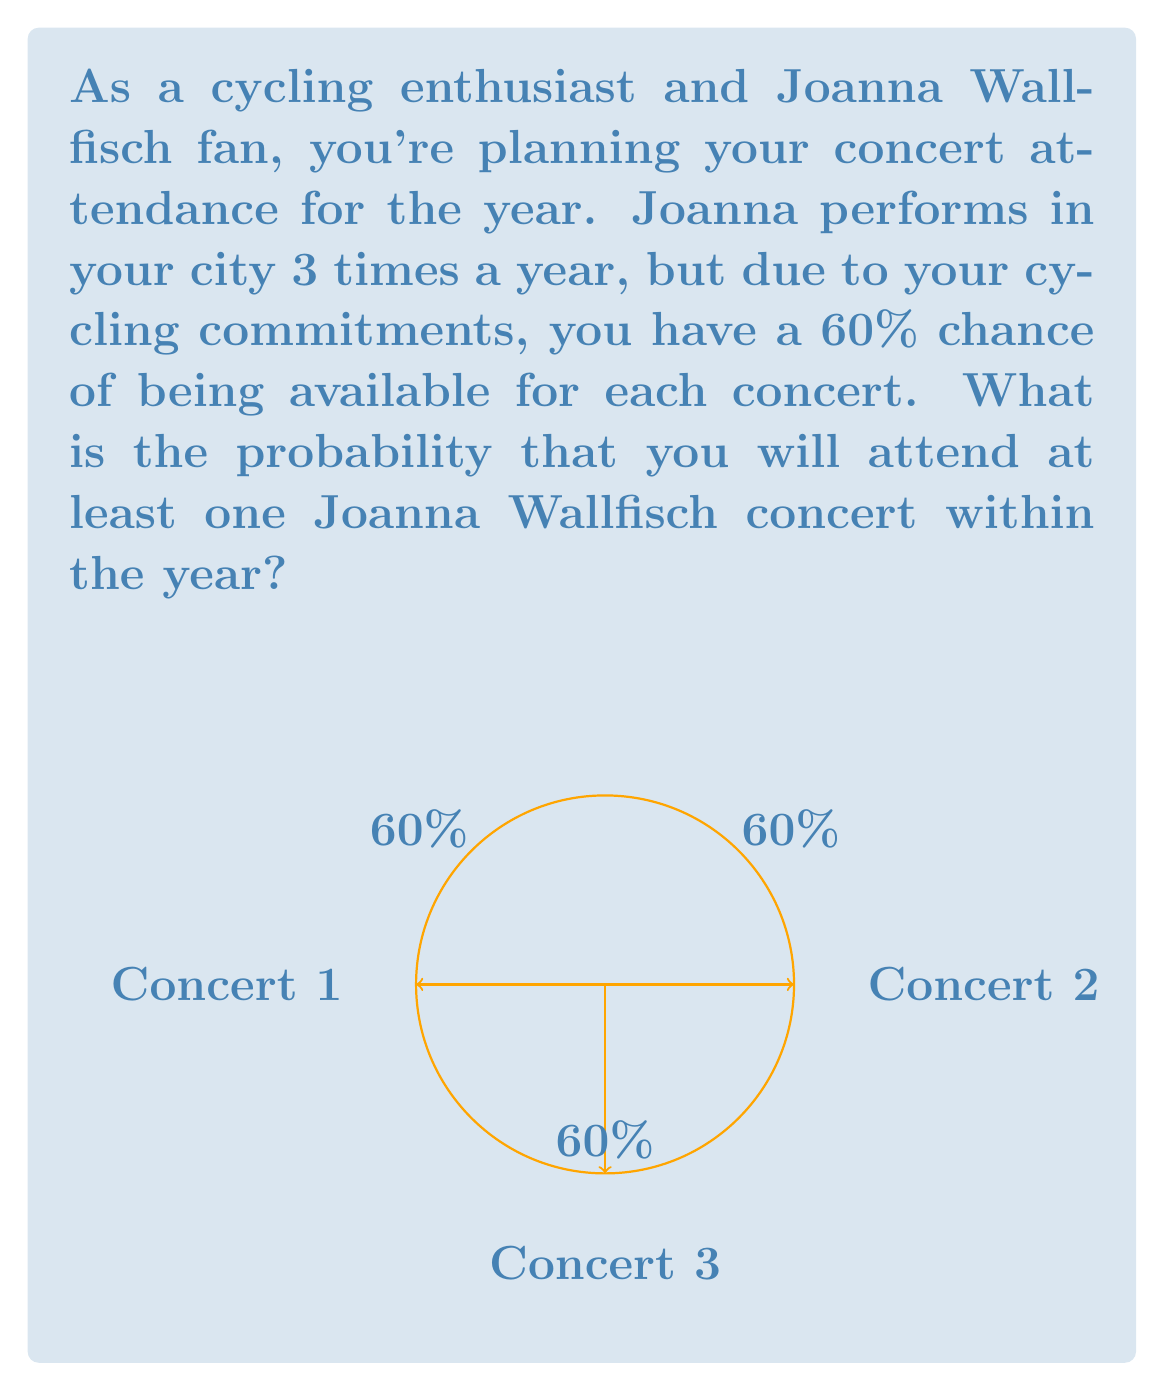Solve this math problem. Let's approach this step-by-step:

1) First, let's calculate the probability of not attending a single concert. For each concert, you have a 60% chance of being available, so the probability of not being available is 40% or 0.4.

2) For you to not attend any concert throughout the year, you would need to miss all three concerts. The probability of this happening is:

   $$P(\text{missing all}) = 0.4 \times 0.4 \times 0.4 = 0.4^3 = 0.064$$

3) Therefore, the probability of attending at least one concert is the opposite of missing all concerts:

   $$P(\text{attending at least one}) = 1 - P(\text{missing all})$$
   $$= 1 - 0.064 = 0.936$$

4) To convert this to a percentage:

   $$0.936 \times 100\% = 93.6\%$$

Thus, there is a 93.6% chance that you will attend at least one Joanna Wallfisch concert within the year.
Answer: 93.6% 